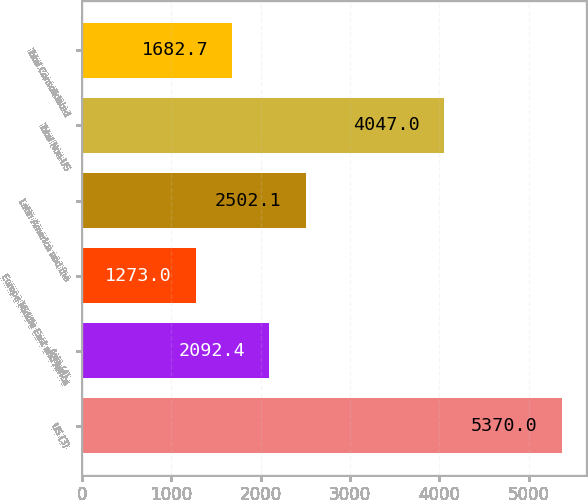Convert chart to OTSL. <chart><loc_0><loc_0><loc_500><loc_500><bar_chart><fcel>US (3)<fcel>Asia (4)<fcel>Europe Middle East and Africa<fcel>Latin America and the<fcel>Total Non-US<fcel>Total Consolidated<nl><fcel>5370<fcel>2092.4<fcel>1273<fcel>2502.1<fcel>4047<fcel>1682.7<nl></chart> 